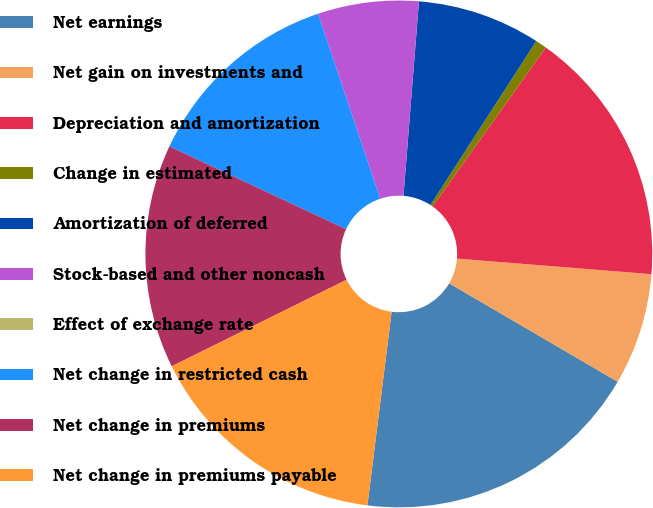<chart> <loc_0><loc_0><loc_500><loc_500><pie_chart><fcel>Net earnings<fcel>Net gain on investments and<fcel>Depreciation and amortization<fcel>Change in estimated<fcel>Amortization of deferred<fcel>Stock-based and other noncash<fcel>Effect of exchange rate<fcel>Net change in restricted cash<fcel>Net change in premiums<fcel>Net change in premiums payable<nl><fcel>18.57%<fcel>7.14%<fcel>16.43%<fcel>0.72%<fcel>7.86%<fcel>6.43%<fcel>0.0%<fcel>12.86%<fcel>14.29%<fcel>15.71%<nl></chart> 